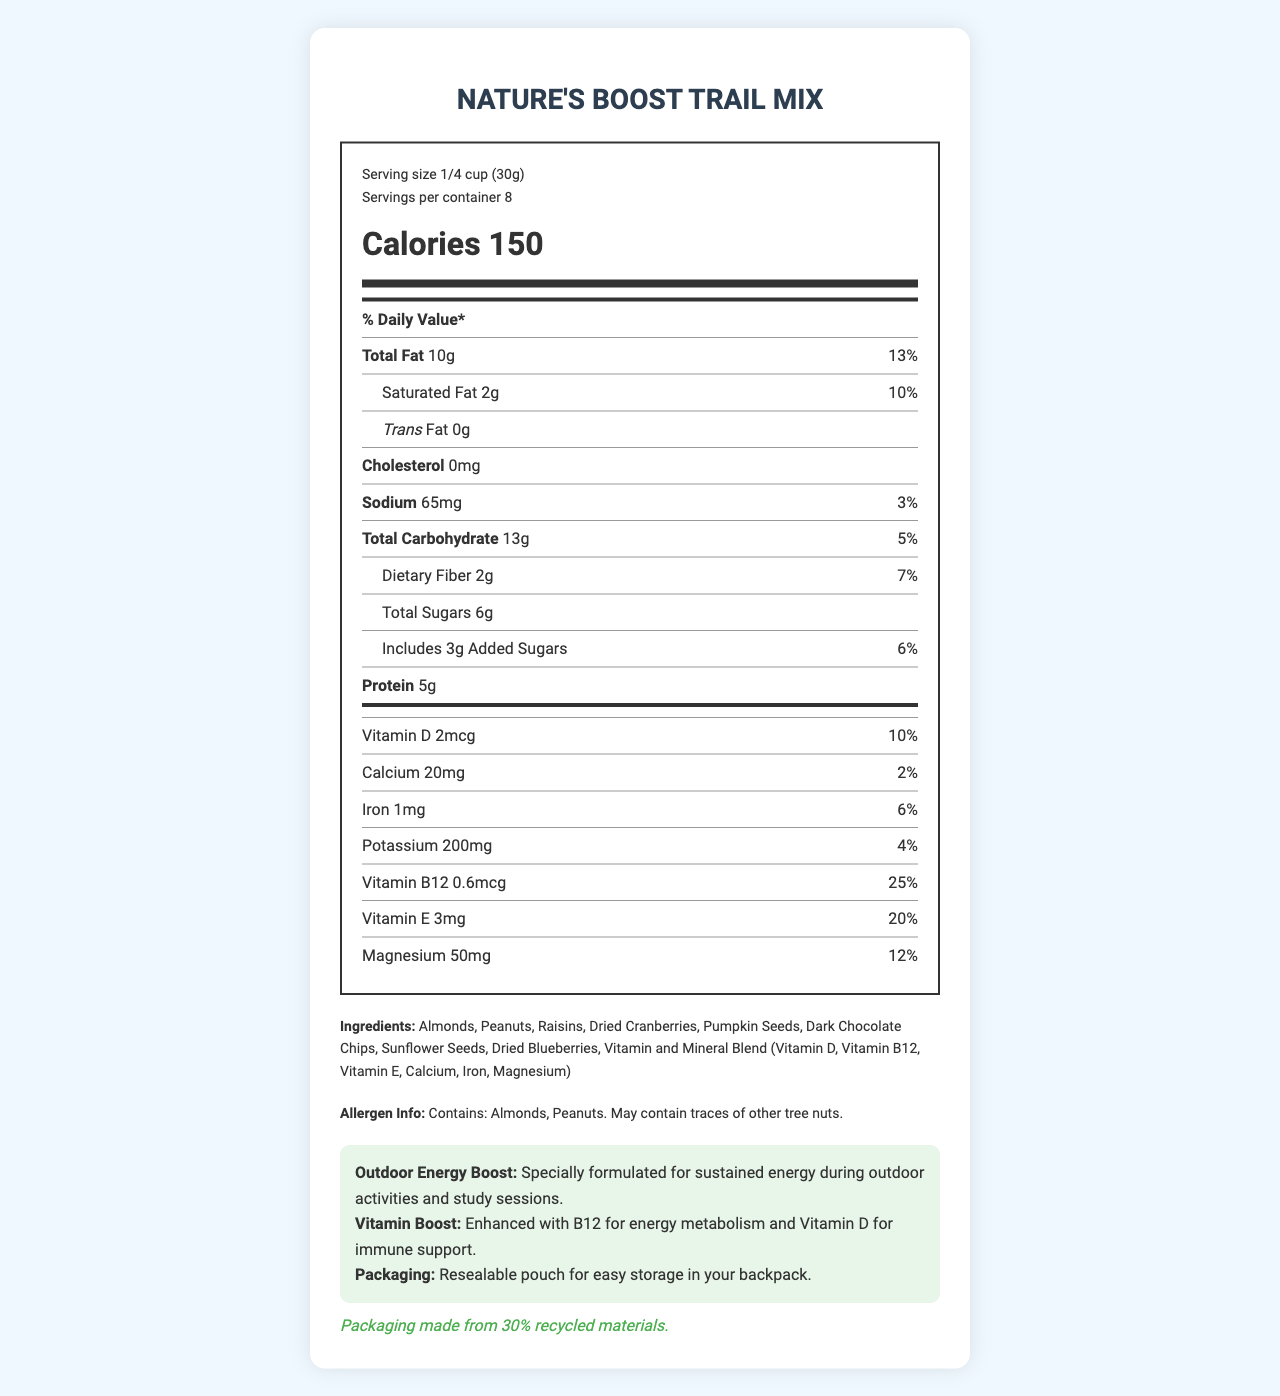what is the serving size for Nature's Boost Trail Mix? The serving size is listed at the top of the nutrition label as "Serving size 1/4 cup (30g)".
Answer: 1/4 cup (30g) how many servings are in one container? The label states "Servings per container: 8" right below the serving size.
Answer: 8 how many calories are in one serving of the trail mix? The number of calories is displayed prominently in large font as "Calories 150".
Answer: 150 what percentage of the daily value for Vitamin E does one serving provide? Under the vitamins section, it is noted that Vitamin E provides 20% of the daily value.
Answer: 20% what is the main benefit of the Vitamin B12 added to the trail mix? In the outdoor info section, it states "Enhanced with B12 for energy metabolism".
Answer: Energy metabolism which of these ingredients are included in the trail mix? A. Cashews B. Almonds C. Walnuts D. Pistachios The ingredients list includes "Almonds", while other choices like Cashews, Walnuts, and Pistachios are not mentioned.
Answer: B. Almonds what is the total fat content in one serving? A. 5g B. 10g C. 15g D. 20g The nutrition facts state "Total Fat 10g".
Answer: B. 10g does the trail mix contain any trans fat? The label shows "Trans Fat 0g".
Answer: No does this product contain any known allergens? The allergen info states "Contains: Almonds, Peanuts. May contain traces of other tree nuts."
Answer: Yes summarize the main nutritional benefits and added features of Nature's Boost Trail Mix. The document highlights the nutrient content including vitamins and minerals, the benefits for outdoor energy, and the environmentally friendly packaging.
Answer: The trail mix provides essential nutrients and vitamins like B12 for energy metabolism and Vitamin D for immune support. It contains healthy fats, protein, dietary fiber, and is specially formulated for sustained energy during outdoor activities. The packaging is eco-friendly with 30% recycled materials. what is the packaging material made from? The sustainability note at the bottom of the document mentions "Packaging made from 30% recycled materials."
Answer: 30% recycled materials how much protein is in one serving of the trail mix? The nutrition facts label lists "Protein 5g".
Answer: 5g what is the primary function of Vitamin D in this trail mix? The outdoor info states "Enhanced with B12 for energy metabolism and Vitamin D for immune support."
Answer: Immune support can I find the total fiber percentage from this document? The document specifies that Dietary Fiber constitutes 7% of the daily value.
Answer: Yes what is the amount of sodium per serving in the trail mix? The nutrition facts show "Sodium 65mg" with a daily value of 3%.
Answer: 65mg how much calcium is included per serving and what percentage of the daily value does it represent? The label lists calcium content as "Calcium 20mg" and the daily value as 2%.
Answer: 20mg, 2% is the packaging resealable? The outdoor info section notes "Resealable pouch for easy storage in your backpack."
Answer: Yes how many grams of saturated fat are included in a single serving? Under the total fat section, "Saturated Fat 2g" is specified with a daily value of 10%.
Answer: 2g can the exact process of manufacturing the packaging material be determined from this document? The document only states that the packaging is made from 30% recycled materials and does not provide details on the manufacturing process.
Answer: No 